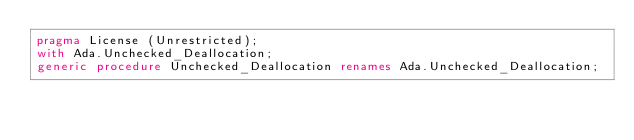Convert code to text. <code><loc_0><loc_0><loc_500><loc_500><_Ada_>pragma License (Unrestricted);
with Ada.Unchecked_Deallocation;
generic procedure Unchecked_Deallocation renames Ada.Unchecked_Deallocation;
</code> 